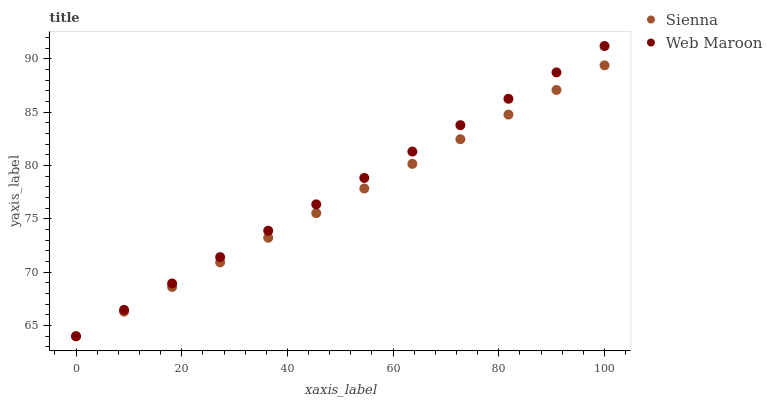Does Sienna have the minimum area under the curve?
Answer yes or no. Yes. Does Web Maroon have the maximum area under the curve?
Answer yes or no. Yes. Does Web Maroon have the minimum area under the curve?
Answer yes or no. No. Is Sienna the smoothest?
Answer yes or no. Yes. Is Web Maroon the roughest?
Answer yes or no. Yes. Is Web Maroon the smoothest?
Answer yes or no. No. Does Sienna have the lowest value?
Answer yes or no. Yes. Does Web Maroon have the highest value?
Answer yes or no. Yes. Does Sienna intersect Web Maroon?
Answer yes or no. Yes. Is Sienna less than Web Maroon?
Answer yes or no. No. Is Sienna greater than Web Maroon?
Answer yes or no. No. 